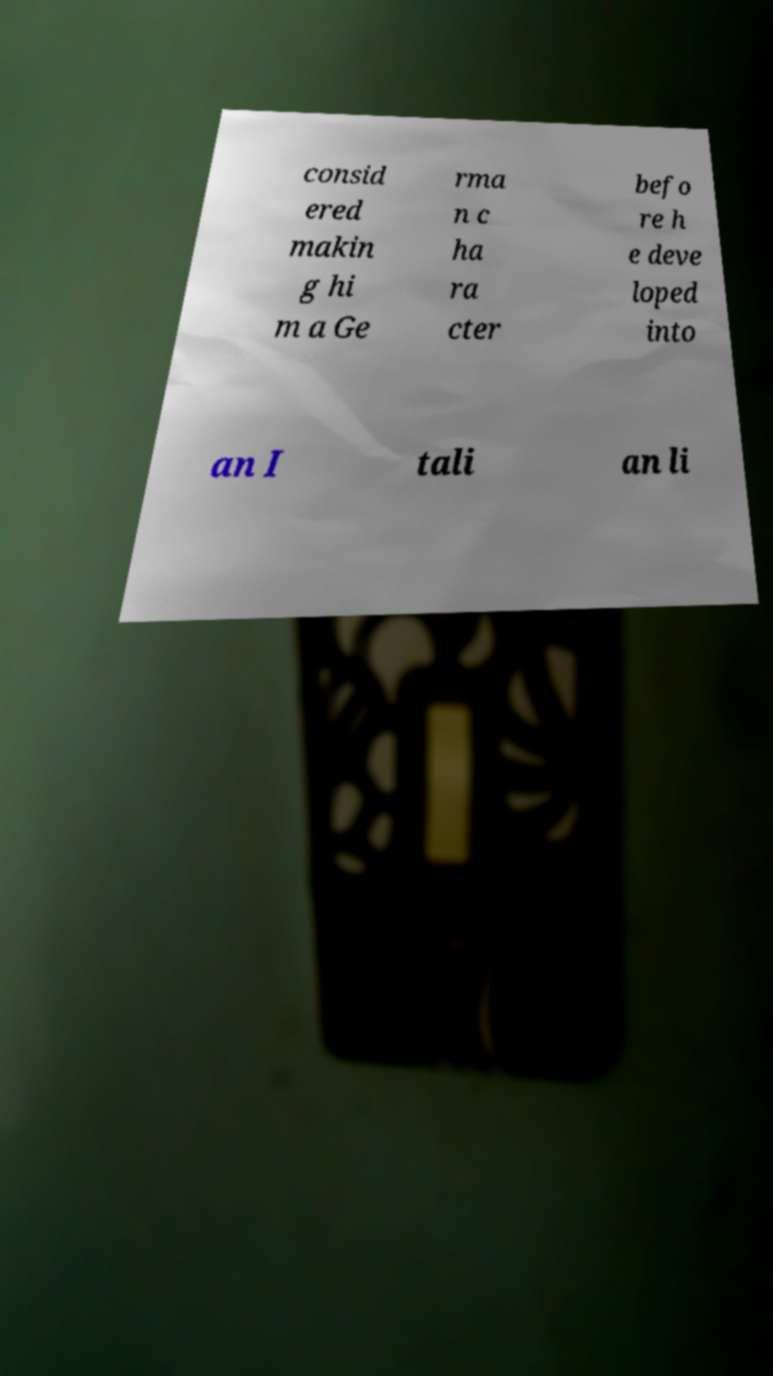Please read and relay the text visible in this image. What does it say? consid ered makin g hi m a Ge rma n c ha ra cter befo re h e deve loped into an I tali an li 